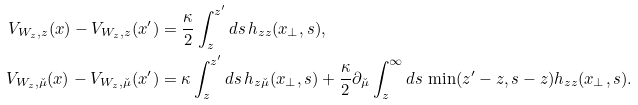<formula> <loc_0><loc_0><loc_500><loc_500>V _ { W _ { z } , z } ( x ) - V _ { W _ { z } , z } ( x ^ { \prime } ) & = \frac { \kappa } { 2 } \int _ { z } ^ { z ^ { \prime } } d s \, h _ { z z } ( x _ { \perp } , s ) , \\ V _ { W _ { z } , \check { \mu } } ( x ) - V _ { W _ { z } , \check { \mu } } ( x ^ { \prime } ) & = \kappa \int _ { z } ^ { z ^ { \prime } } d s \, h _ { z \check { \mu } } ( x _ { \perp } , s ) + \frac { \kappa } { 2 } \partial _ { \check { \mu } } \int _ { z } ^ { \infty } d s \, \min ( z ^ { \prime } - z , s - z ) h _ { z z } ( x _ { \perp } , s ) .</formula> 